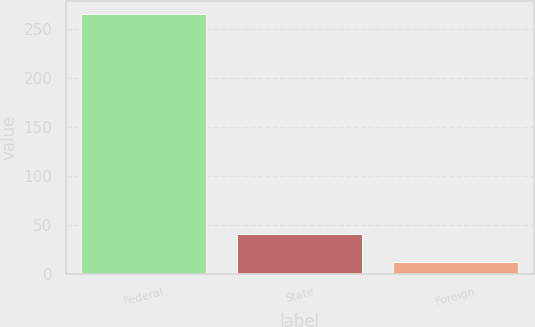Convert chart to OTSL. <chart><loc_0><loc_0><loc_500><loc_500><bar_chart><fcel>Federal<fcel>State<fcel>Foreign<nl><fcel>266.2<fcel>41<fcel>12.2<nl></chart> 